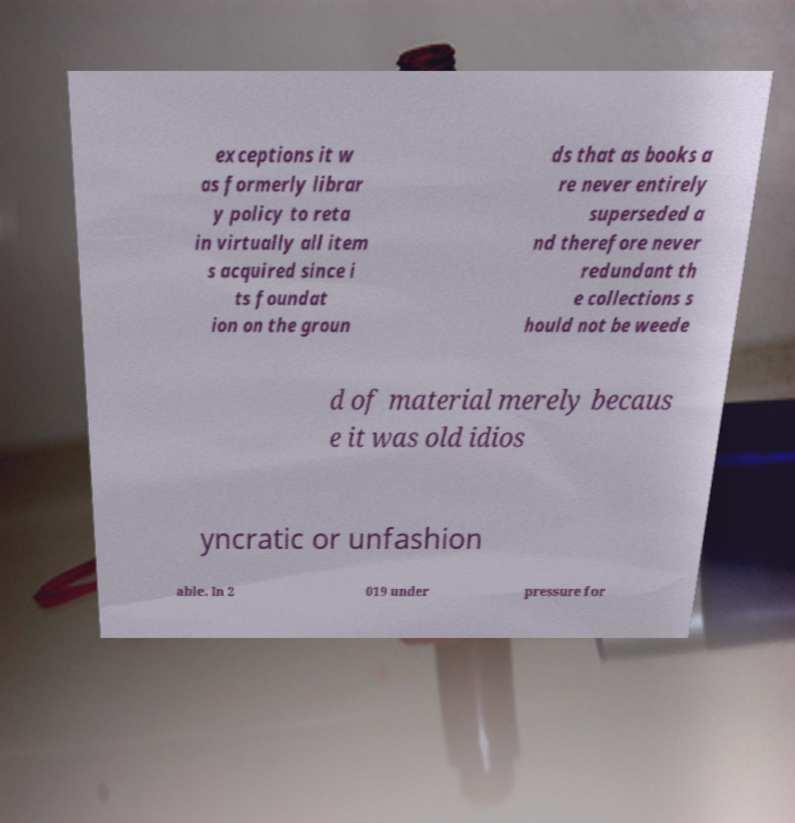Can you read and provide the text displayed in the image?This photo seems to have some interesting text. Can you extract and type it out for me? exceptions it w as formerly librar y policy to reta in virtually all item s acquired since i ts foundat ion on the groun ds that as books a re never entirely superseded a nd therefore never redundant th e collections s hould not be weede d of material merely becaus e it was old idios yncratic or unfashion able. In 2 019 under pressure for 